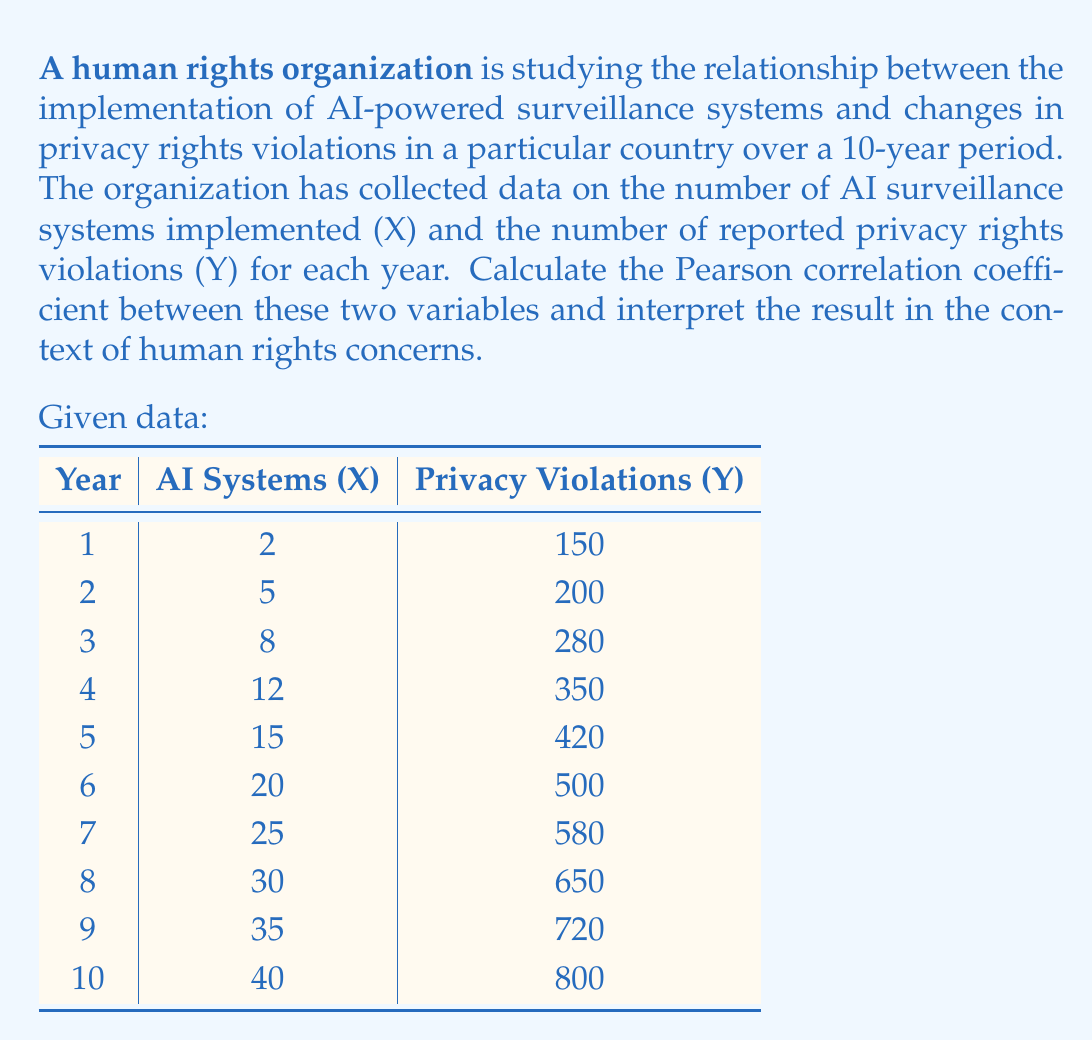Can you answer this question? To calculate the Pearson correlation coefficient (r) between the number of AI surveillance systems (X) and the number of reported privacy rights violations (Y), we'll use the formula:

$$ r = \frac{\sum_{i=1}^{n} (x_i - \bar{x})(y_i - \bar{y})}{\sqrt{\sum_{i=1}^{n} (x_i - \bar{x})^2 \sum_{i=1}^{n} (y_i - \bar{y})^2}} $$

Where:
$x_i$ and $y_i$ are individual values of X and Y
$\bar{x}$ and $\bar{y}$ are the means of X and Y

Step 1: Calculate the means
$\bar{x} = \frac{2 + 5 + 8 + 12 + 15 + 20 + 25 + 30 + 35 + 40}{10} = 19.2$
$\bar{y} = \frac{150 + 200 + 280 + 350 + 420 + 500 + 580 + 650 + 720 + 800}{10} = 465$

Step 2: Calculate $(x_i - \bar{x})$, $(y_i - \bar{y})$, $(x_i - \bar{x})^2$, $(y_i - \bar{y})^2$, and $(x_i - \bar{x})(y_i - \bar{y})$ for each data point.

Step 3: Sum up the calculated values:
$\sum (x_i - \bar{x})(y_i - \bar{y}) = 54,130$
$\sum (x_i - \bar{x})^2 = 1,729.6$
$\sum (y_i - \bar{y})^2 = 351,250$

Step 4: Apply the formula:
$$ r = \frac{54,130}{\sqrt{1,729.6 \times 351,250}} = \frac{54,130}{24,678.95} \approx 0.9939 $$

Interpretation: The Pearson correlation coefficient of approximately 0.9939 indicates a very strong positive correlation between the implementation of AI surveillance systems and reported privacy rights violations. This suggests that as more AI surveillance systems are implemented, there is a corresponding increase in privacy rights violations.

From a human rights perspective, this strong correlation raises significant concerns about the impact of AI technologies on privacy rights. It suggests that the proliferation of AI-powered surveillance systems may be linked to an erosion of privacy protections, potentially infringing on fundamental human rights.
Answer: The Pearson correlation coefficient is approximately 0.9939, indicating a very strong positive correlation between the implementation of AI surveillance systems and reported privacy rights violations. 